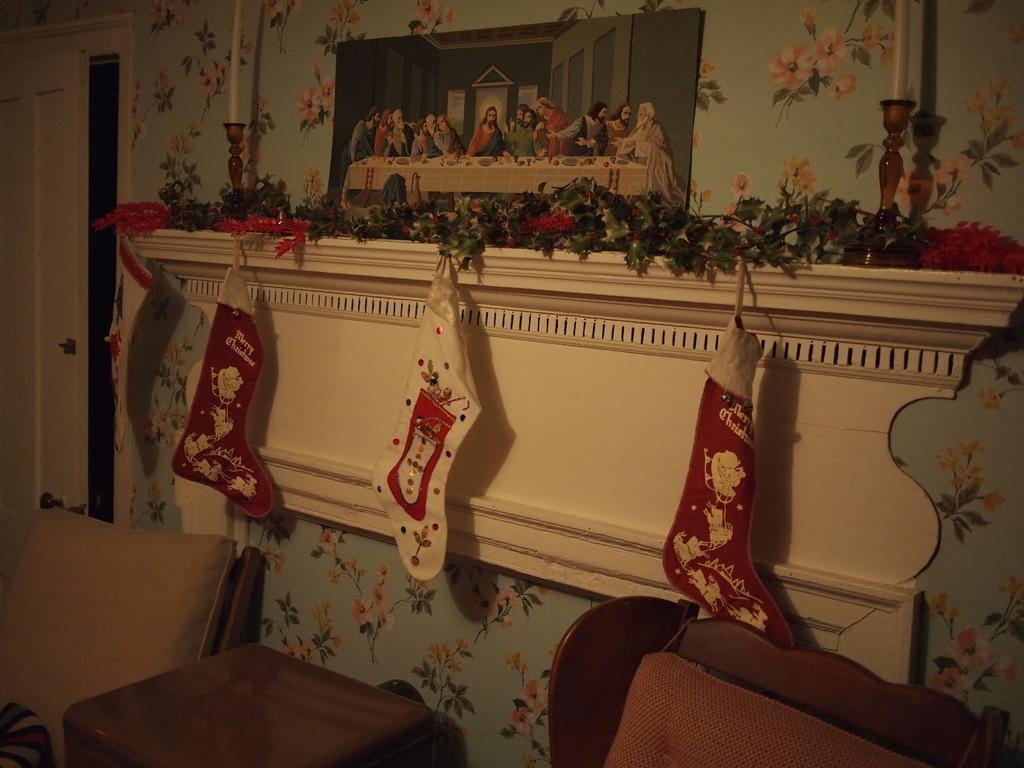Please provide a concise description of this image. In this image we can see door, wall hanging, candles, candle holders, decors, side table and chairs. 